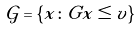Convert formula to latex. <formula><loc_0><loc_0><loc_500><loc_500>\mathcal { G } = \{ x \colon G x \leq v \}</formula> 